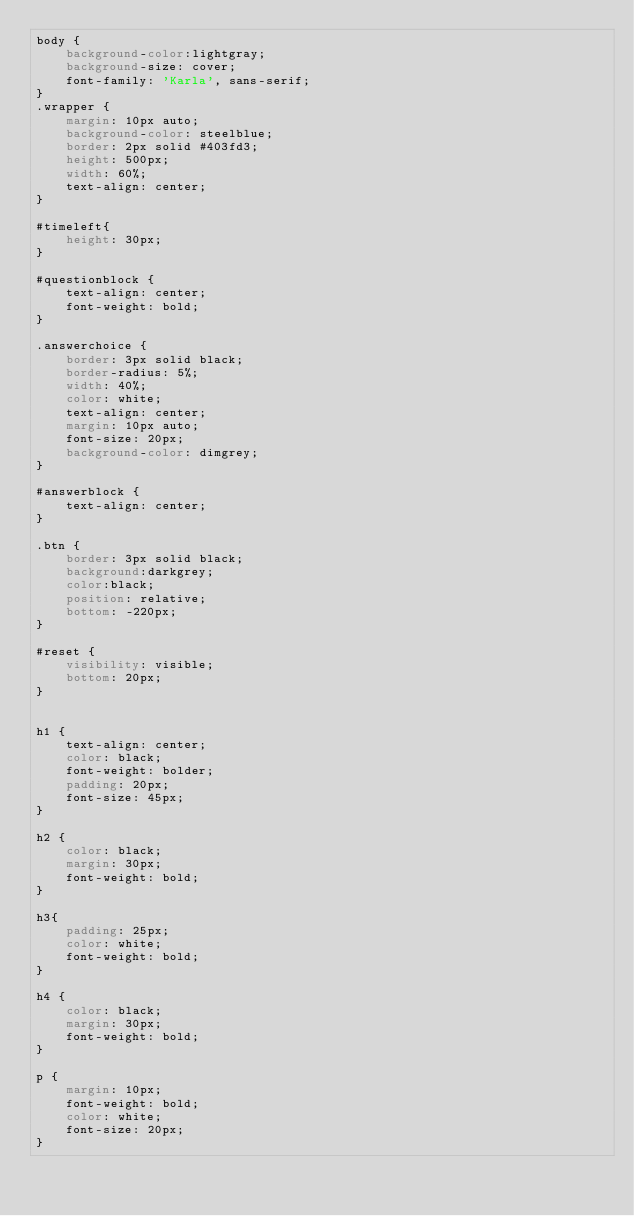<code> <loc_0><loc_0><loc_500><loc_500><_CSS_>body {
    background-color:lightgray;
    background-size: cover;
    font-family: 'Karla', sans-serif;
}
.wrapper {
    margin: 10px auto;
    background-color: steelblue;
    border: 2px solid #403fd3;
    height: 500px;
    width: 60%;
    text-align: center;
}

#timeleft{
    height: 30px;
}

#questionblock {
    text-align: center;
    font-weight: bold;
}

.answerchoice {
    border: 3px solid black;
    border-radius: 5%;
    width: 40%;
    color: white;
    text-align: center;
    margin: 10px auto;
    font-size: 20px;
    background-color: dimgrey;
}

#answerblock {
    text-align: center;
}

.btn {  
    border: 3px solid black;
    background:darkgrey;
    color:black;
    position: relative;
    bottom: -220px;
}

#reset {
    visibility: visible;
    bottom: 20px;
}


h1 {
    text-align: center;
    color: black;
    font-weight: bolder;
    padding: 20px;
    font-size: 45px;
}

h2 {
    color: black;
    margin: 30px;
    font-weight: bold;
}

h3{
    padding: 25px;
    color: white;
    font-weight: bold;
}

h4 {
    color: black;
    margin: 30px;
    font-weight: bold;
}

p {
    margin: 10px;
    font-weight: bold;
    color: white;
    font-size: 20px;
}
</code> 